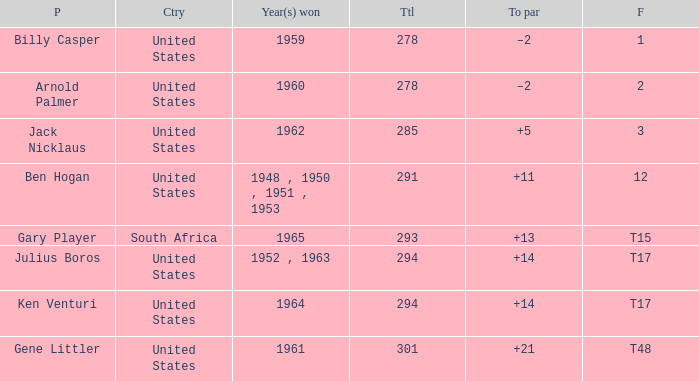Which country won in the year 1962? United States. 